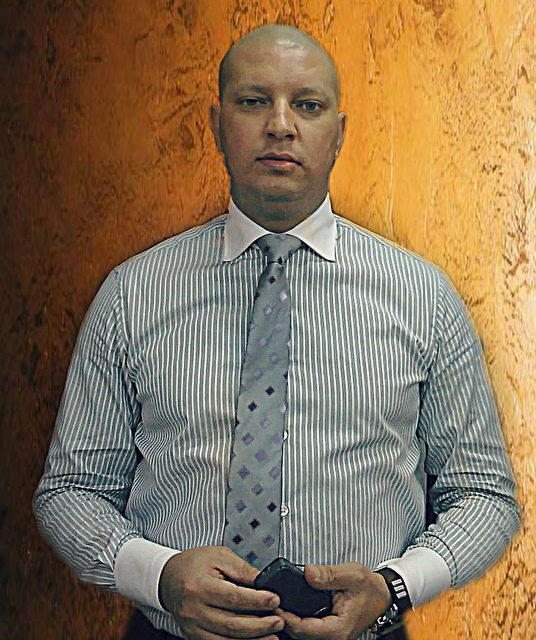<image>What is the man holding? I am not sure what the man is holding. It might be a phone or a beeper. What is the man holding? I don't know what the man is holding. It can be a beeper, cell phone, or phone. 